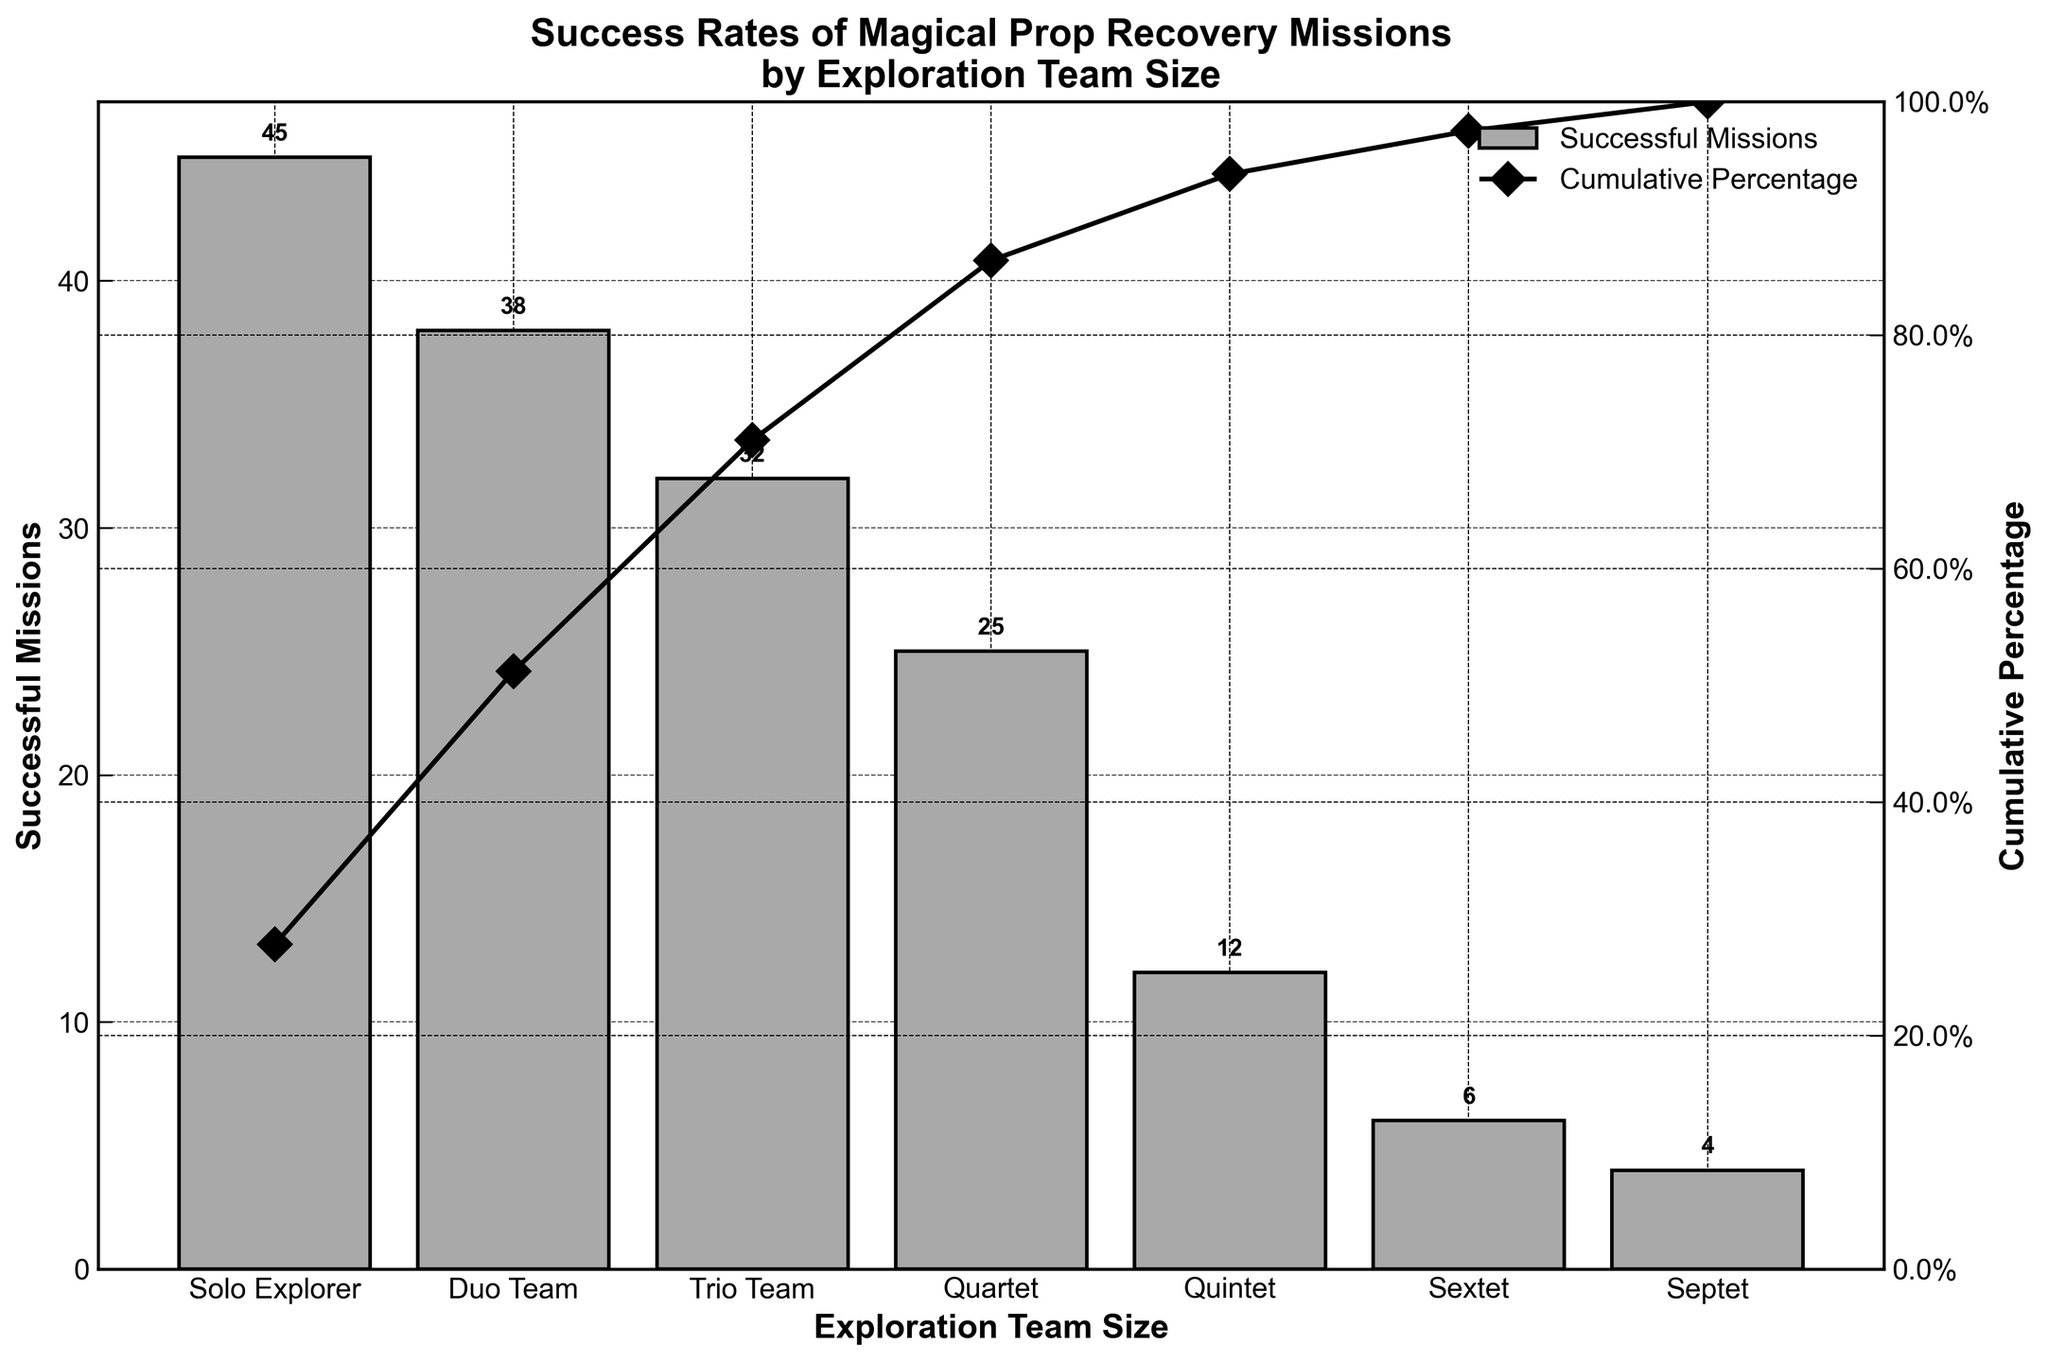What is the title of the chart? The title of the chart is displayed at the top of the figure. It reads "Success Rates of Magical Prop Recovery Missions by Exploration Team Size".
Answer: Success Rates of Magical Prop Recovery Missions by Exploration Team Size How many successful missions were completed by duo teams? The bar labeled "Duo Team" indicates the number of successful missions they completed. This value is shown as 38 above the corresponding bar.
Answer: 38 Which team size had the fewest successful missions? By comparing the heights of all bars, the "Septet" (seven-member team) has the shortest bar, indicating they had the fewest successful missions at 4.
Answer: Septet What is the cumulative percentage after quartet teams? The cumulative percentage line plotted on the secondary y-axis intersects the quartet team point, which reads 86.4%.
Answer: 86.4% What is the cumulative percentage difference between duet and quartet teams? The cumulative percentage for duet teams is 51.2%, and for quartet teams it is 86.4%. The difference is calculated as 86.4% - 51.2% = 35.2%.
Answer: 35.2% How many teams had over 30 successful missions? Based on the bars, the teams with over 30 successful missions are "Solo Explorer" (45), "Duo Team" (38), and "Trio Team" (32). That's three teams.
Answer: 3 Which team size's successful missions brought the cumulative percentage from below 90% to above 90%? Looking at the cumulative percentage line, the "Quintet" team brought the cumulative percentage from 86.4% (below 90%) to 93.8% (above 90%).
Answer: Quintet What is the combined total of successful missions by solo explorers and trio teams? Solo explorers had 45 successful missions, and trio teams had 32. The combined total is 45 + 32 = 77.
Answer: 77 Which exploration team size has the second lowest successful missions count? The bars indicate the number of successful missions, where the second lowest is for "Sextet" with 6 successful missions.
Answer: Sextet 